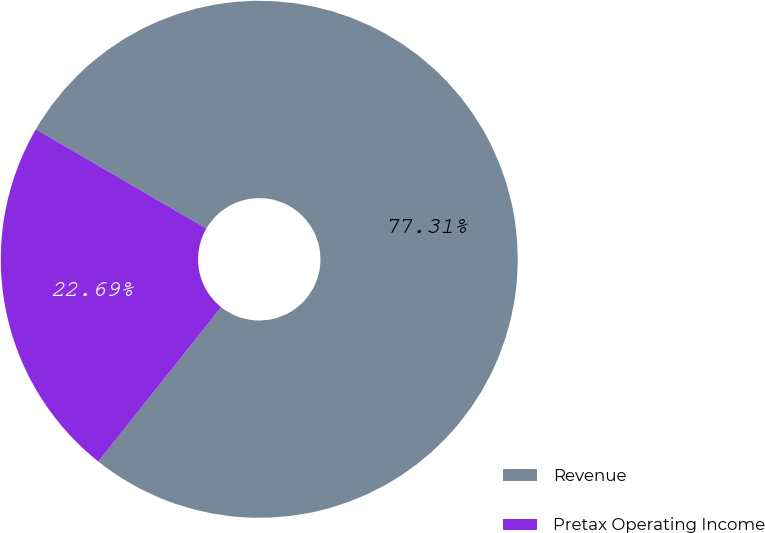<chart> <loc_0><loc_0><loc_500><loc_500><pie_chart><fcel>Revenue<fcel>Pretax Operating Income<nl><fcel>77.31%<fcel>22.69%<nl></chart> 